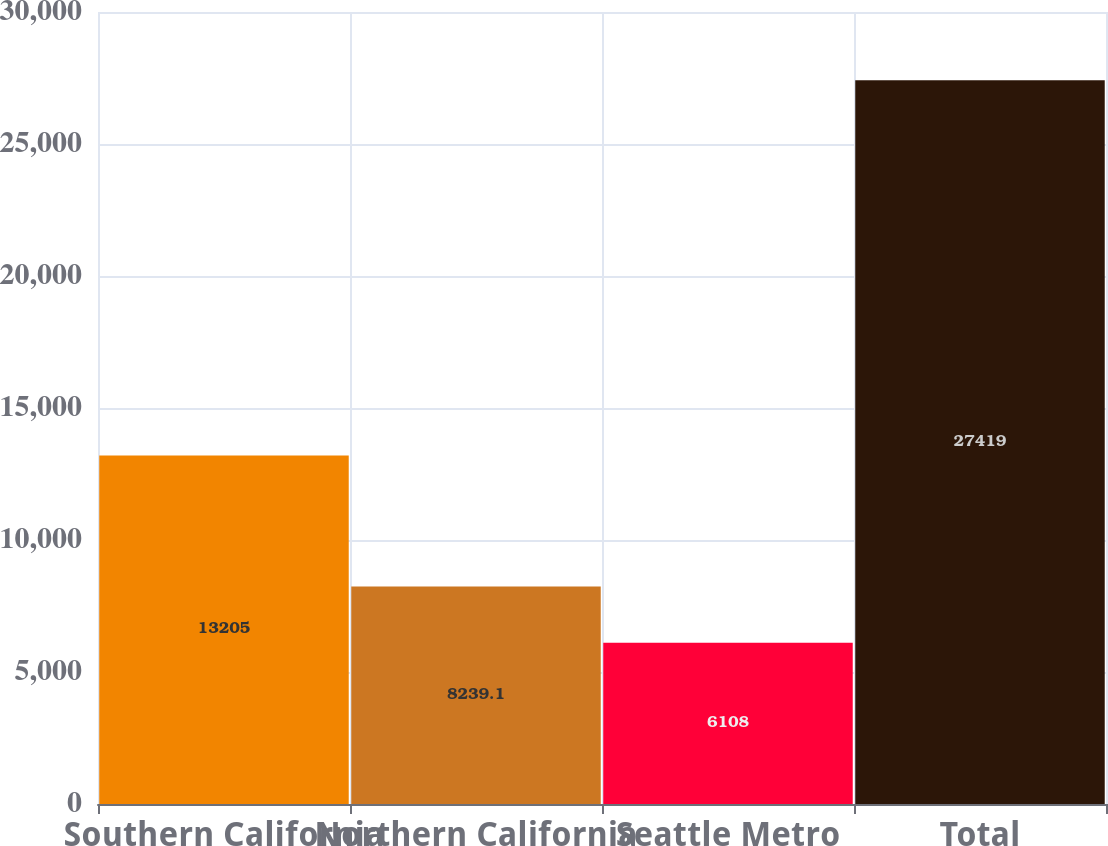Convert chart. <chart><loc_0><loc_0><loc_500><loc_500><bar_chart><fcel>Southern California<fcel>Northern California<fcel>Seattle Metro<fcel>Total<nl><fcel>13205<fcel>8239.1<fcel>6108<fcel>27419<nl></chart> 